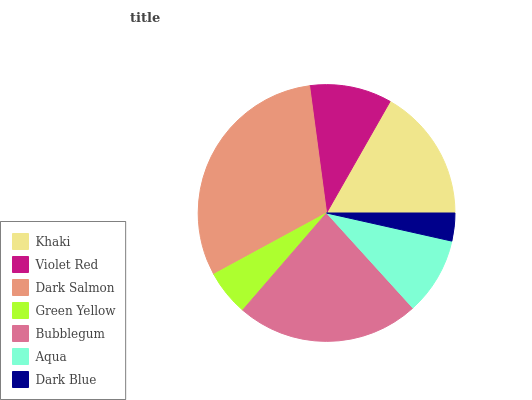Is Dark Blue the minimum?
Answer yes or no. Yes. Is Dark Salmon the maximum?
Answer yes or no. Yes. Is Violet Red the minimum?
Answer yes or no. No. Is Violet Red the maximum?
Answer yes or no. No. Is Khaki greater than Violet Red?
Answer yes or no. Yes. Is Violet Red less than Khaki?
Answer yes or no. Yes. Is Violet Red greater than Khaki?
Answer yes or no. No. Is Khaki less than Violet Red?
Answer yes or no. No. Is Violet Red the high median?
Answer yes or no. Yes. Is Violet Red the low median?
Answer yes or no. Yes. Is Aqua the high median?
Answer yes or no. No. Is Khaki the low median?
Answer yes or no. No. 